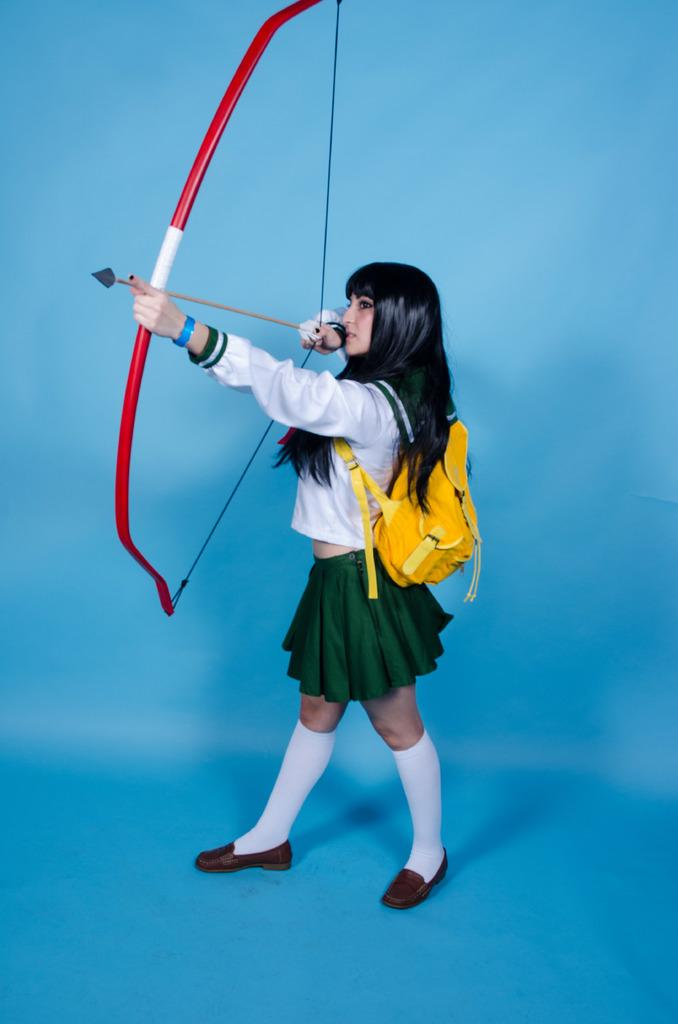Who is the main subject in the image? There is a woman in the image. What is the woman wearing? The woman is wearing a bag. What is the woman holding in the image? The woman is holding a bow and arrow. What is the color of the surface in the image? The image has a blue surface. What is the color of the background in the image? The image has a blue background. How many passengers are visible in the image? There are no passengers visible in the image; it features a woman holding a bow and arrow. Can you see any feathers on the woman's clothing in the image? There are no feathers visible on the woman's clothing in the image. 